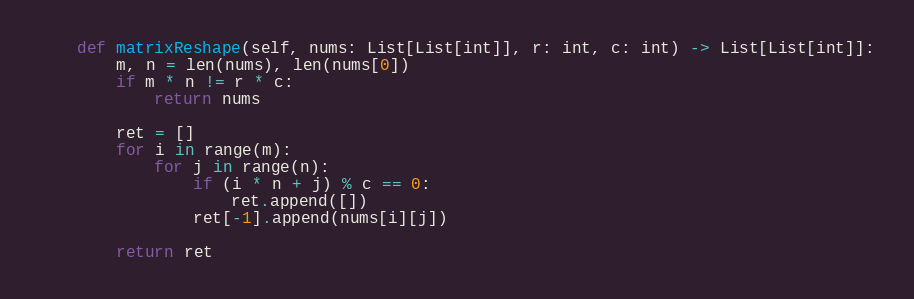Convert code to text. <code><loc_0><loc_0><loc_500><loc_500><_Python_>    def matrixReshape(self, nums: List[List[int]], r: int, c: int) -> List[List[int]]:
        m, n = len(nums), len(nums[0])
        if m * n != r * c:
            return nums

        ret = []
        for i in range(m):
            for j in range(n):
                if (i * n + j) % c == 0:
                    ret.append([])
                ret[-1].append(nums[i][j])

        return ret 
</code> 